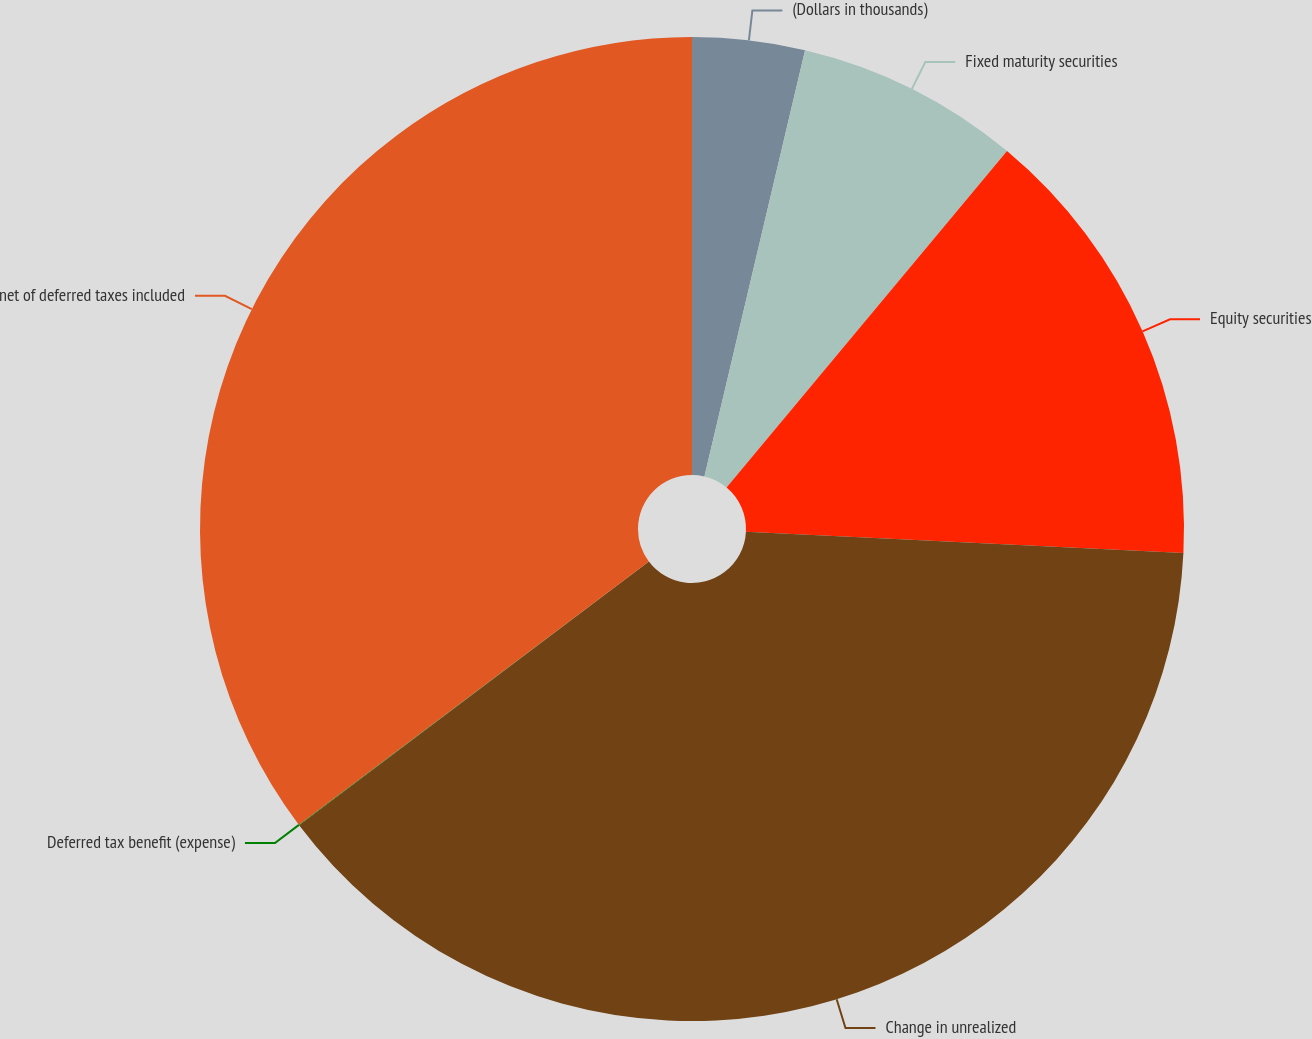Convert chart. <chart><loc_0><loc_0><loc_500><loc_500><pie_chart><fcel>(Dollars in thousands)<fcel>Fixed maturity securities<fcel>Equity securities<fcel>Change in unrealized<fcel>Deferred tax benefit (expense)<fcel>net of deferred taxes included<nl><fcel>3.69%<fcel>7.37%<fcel>14.72%<fcel>38.94%<fcel>0.02%<fcel>35.26%<nl></chart> 